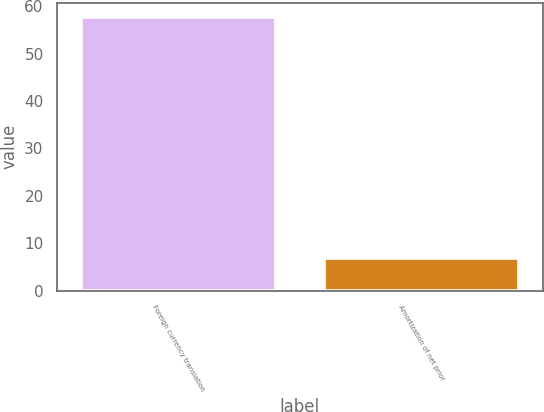Convert chart. <chart><loc_0><loc_0><loc_500><loc_500><bar_chart><fcel>Foreign currency translation<fcel>Amortization of net prior<nl><fcel>57.8<fcel>6.9<nl></chart> 